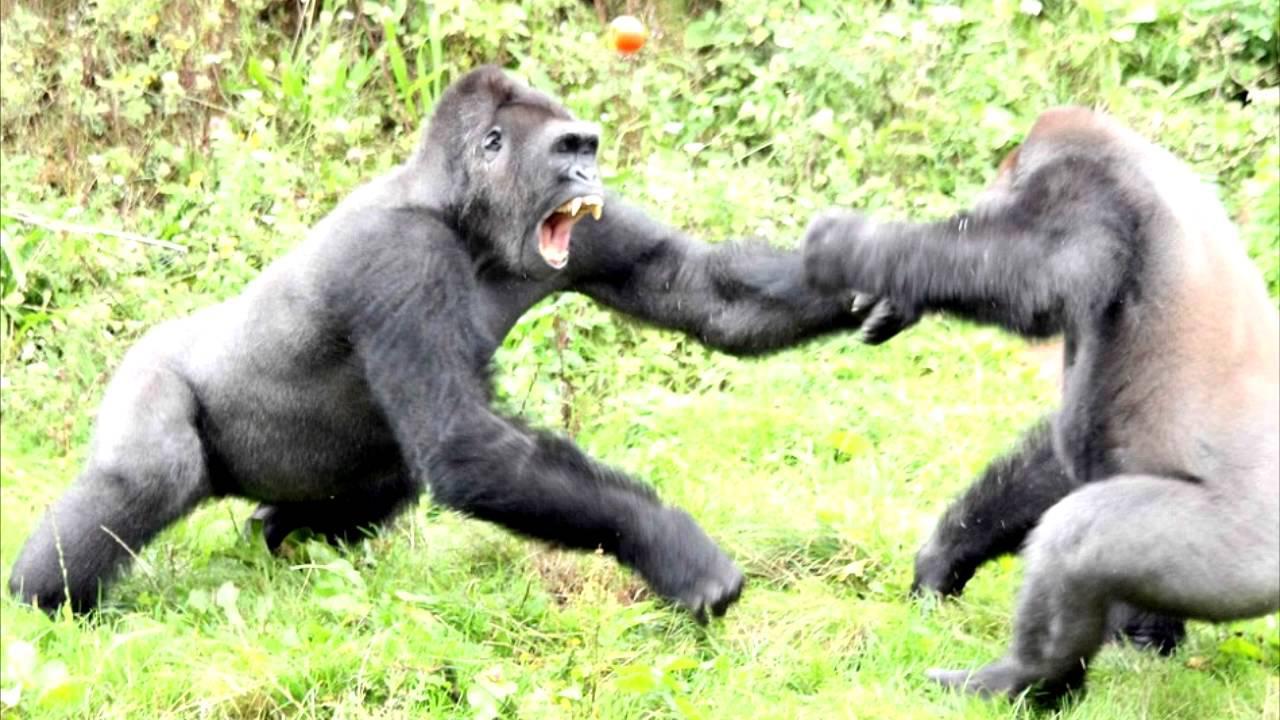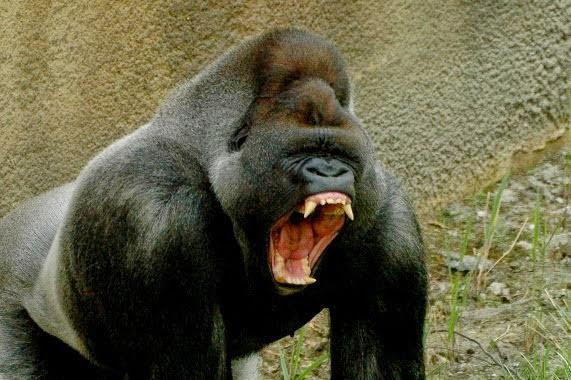The first image is the image on the left, the second image is the image on the right. Analyze the images presented: Is the assertion "One of the images contains two gorillas that are fighting." valid? Answer yes or no. Yes. 